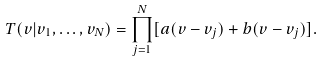<formula> <loc_0><loc_0><loc_500><loc_500>T ( v | v _ { 1 } , \dots , v _ { N } ) = \prod _ { j = 1 } ^ { N } [ a ( v - v _ { j } ) + b ( v - v _ { j } ) ] .</formula> 